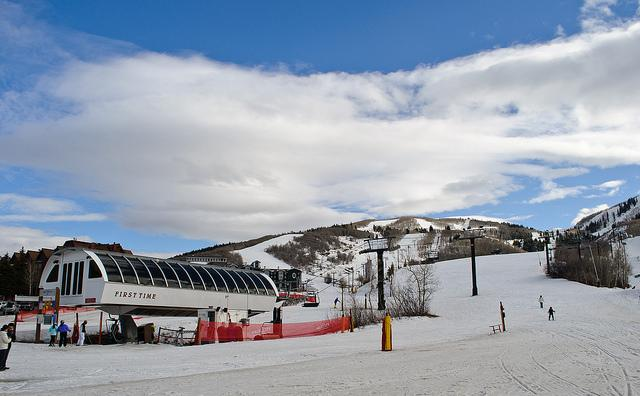Which skiers gather under the pavilion nearest here? beginners 